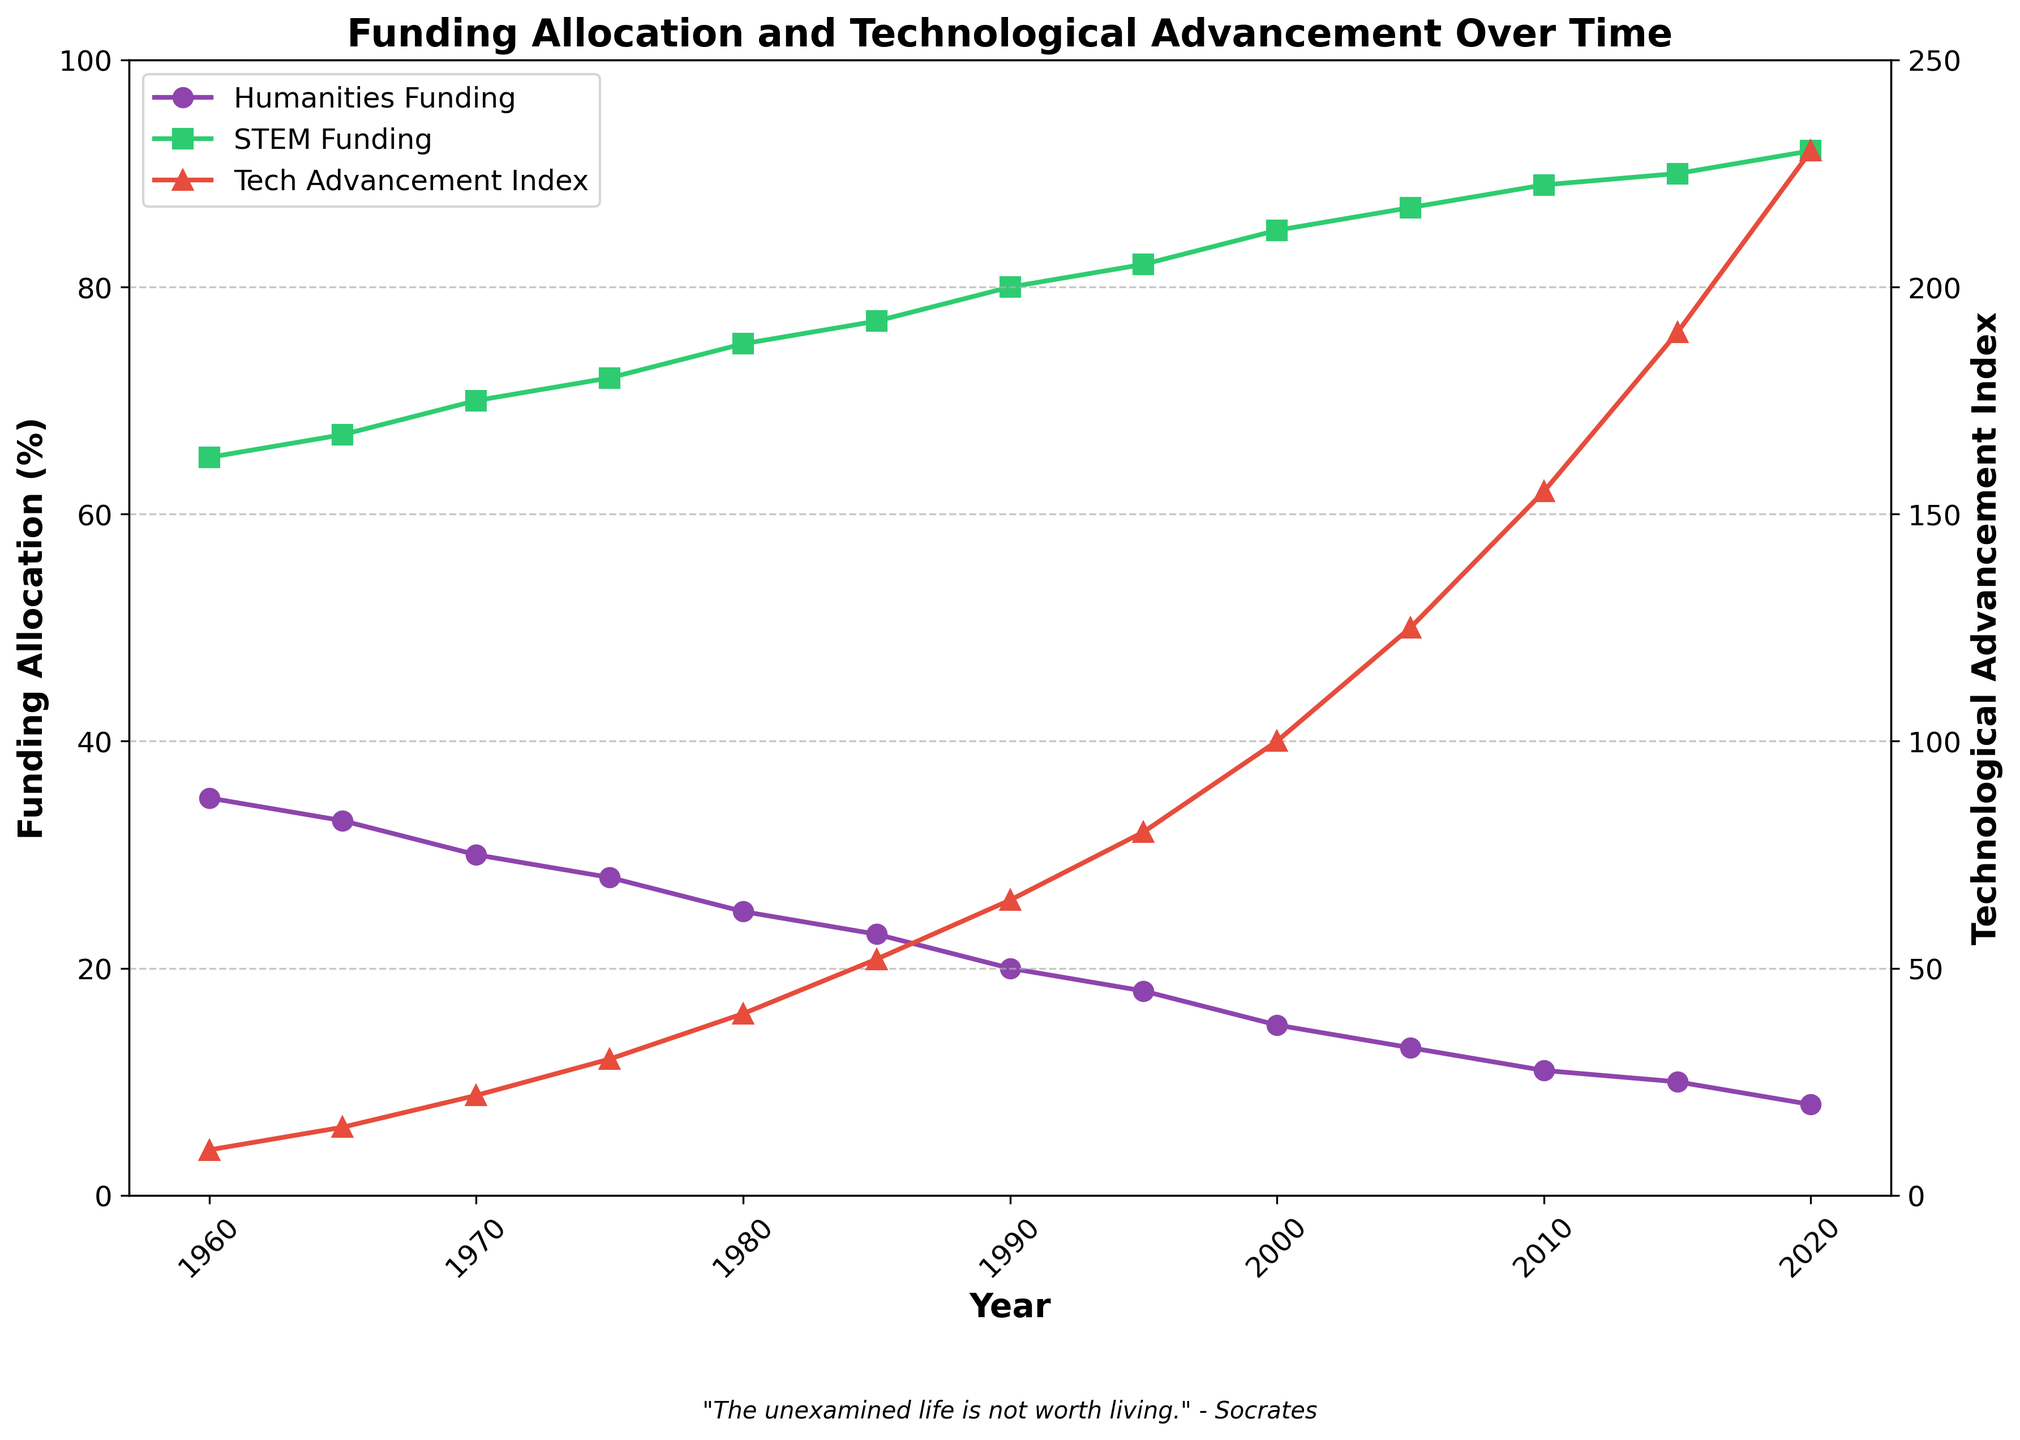What's the trend observed in Humanities Funding (%) over the years from 1960 to 2020? The Humanities Funding (%) consistently decreases from 35% in 1960 to 8% in 2020, indicating a steady decline over the 60-year period.
Answer: Decreasing trend At what year did STEM Funding (%) reach 85%? By observing the plot, STEM Funding (%) reached 85% in the year 2000, as that's where the funding line meets the 85% mark.
Answer: 2000 Compare the growth of the Technological Advancement Index from 1960 to 1990 with its growth from 1990 to 2020. From 1960 to 1990, the Technological Advancement Index grew from 10 to 65, a difference of 55 units. From 1990 to 2020, it increased from 65 to 230, a difference of 165 units. The growth from 1990 to 2020 was significantly higher.
Answer: Greater growth from 1990 to 2020 What is the ratio of STEM Funding (%) to Humanities Funding (%) in the year 2020? In 2020, STEM Funding is 92% and Humanities Funding is 8%. The ratio is calculated by dividing STEM Funding by Humanities Funding: 92 / 8 = 11.5.
Answer: 11.5 Describe the visual relationship between STEM Funding (%) and the Technological Advancement Index. As represented in the chart, there's a strong positive correlation: as STEM Funding (%) increases over the years, the Technological Advancement Index also rises, visually depicted by two lines ascending together.
Answer: Positive correlation Calculate the average annual increase in the Technological Advancement Index from 1960 to 2020. The Technological Advancement Index increased from 10 in 1960 to 230 in 2020 over 60 years. The average annual increase is (230 - 10) / 60 = 220 / 60 = ~3.67 units per year.
Answer: ~3.67 units per year Which year marks the highest difference between STEM Funding (%) and Humanities Funding (%)? The year 2020 shows the maximum difference, 92% - 8% = 84% difference, as derived from the plot data where the funding lines are most distant.
Answer: 2020 What visual features are used to distinguish between the Humanities funding, STEM funding, and Technological Advancement Index in the plot? The Humanities funding is plotted with circles and a purple line, STEM funding with squares and a green line, and the Technological Advancement Index with triangles and a red line. Different markers and colors are used for clarity.
Answer: Markers and colors 